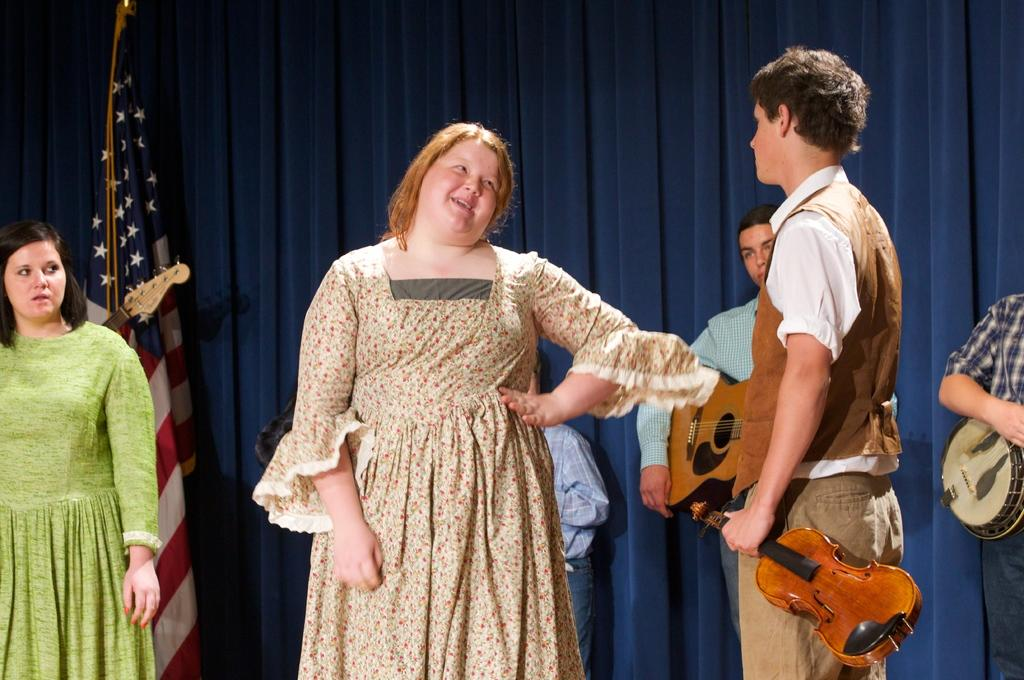What are the people in the image doing? There are persons standing in the image, and one person is holding a guitar. Can you describe the person holding the guitar? The person holding the guitar is male. What is the expression of the other person in the image? The other person, who is female, is smiling. What can be seen in the background of the image? There is a curtain in the background of the image. What other object is present in the image? There is a flag in the image. How many frogs are jumping around in the image? There are no frogs present in the image. What type of balls are being used by the geese in the image? There are no geese or balls present in the image. 